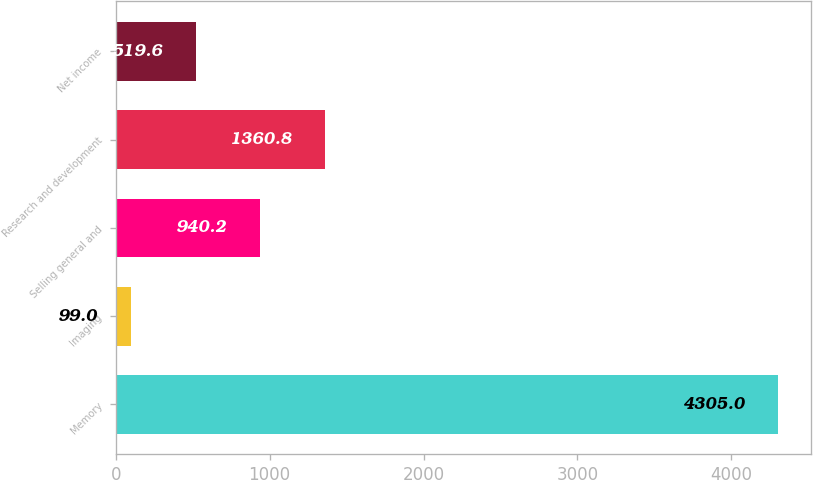Convert chart to OTSL. <chart><loc_0><loc_0><loc_500><loc_500><bar_chart><fcel>Memory<fcel>Imaging<fcel>Selling general and<fcel>Research and development<fcel>Net income<nl><fcel>4305<fcel>99<fcel>940.2<fcel>1360.8<fcel>519.6<nl></chart> 